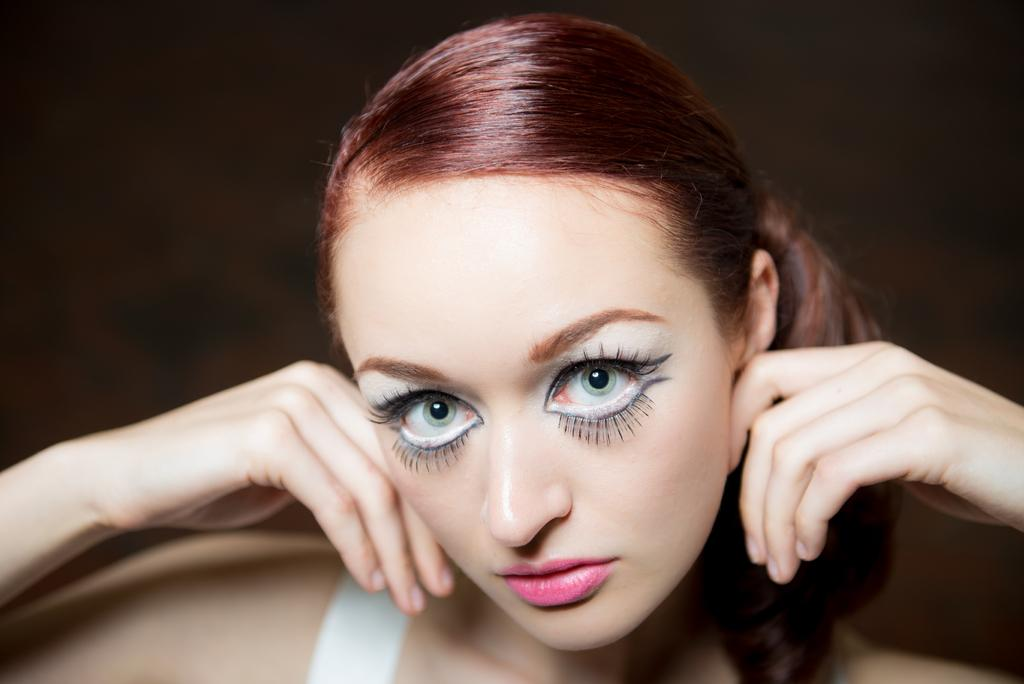Who is the main subject in the image? There is a woman in the image. What makeup elements can be seen on the woman's face? The woman is wearing eyeliner, eyelashes, and lipstick. How many legs does the moon have in the image? There is no moon present in the image, and therefore no legs can be counted. 